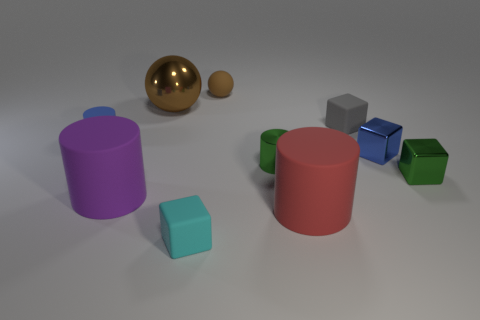What number of large things are the same color as the small sphere?
Keep it short and to the point. 1. What is the size of the rubber ball that is the same color as the large shiny ball?
Ensure brevity in your answer.  Small. There is a tiny sphere behind the red object; is it the same color as the big sphere?
Keep it short and to the point. Yes. Is there any other thing that is the same color as the small sphere?
Provide a succinct answer. Yes. Does the small rubber ball have the same color as the big object that is behind the tiny gray matte cube?
Offer a very short reply. Yes. What shape is the metal thing that is the same color as the metallic cylinder?
Offer a terse response. Cube. Are there any other large spheres of the same color as the matte ball?
Offer a terse response. Yes. Is the large brown thing made of the same material as the big purple object?
Your answer should be compact. No. Is the small matte sphere the same color as the large shiny sphere?
Give a very brief answer. Yes. Are there fewer large blue rubber cubes than brown metal objects?
Give a very brief answer. Yes. 